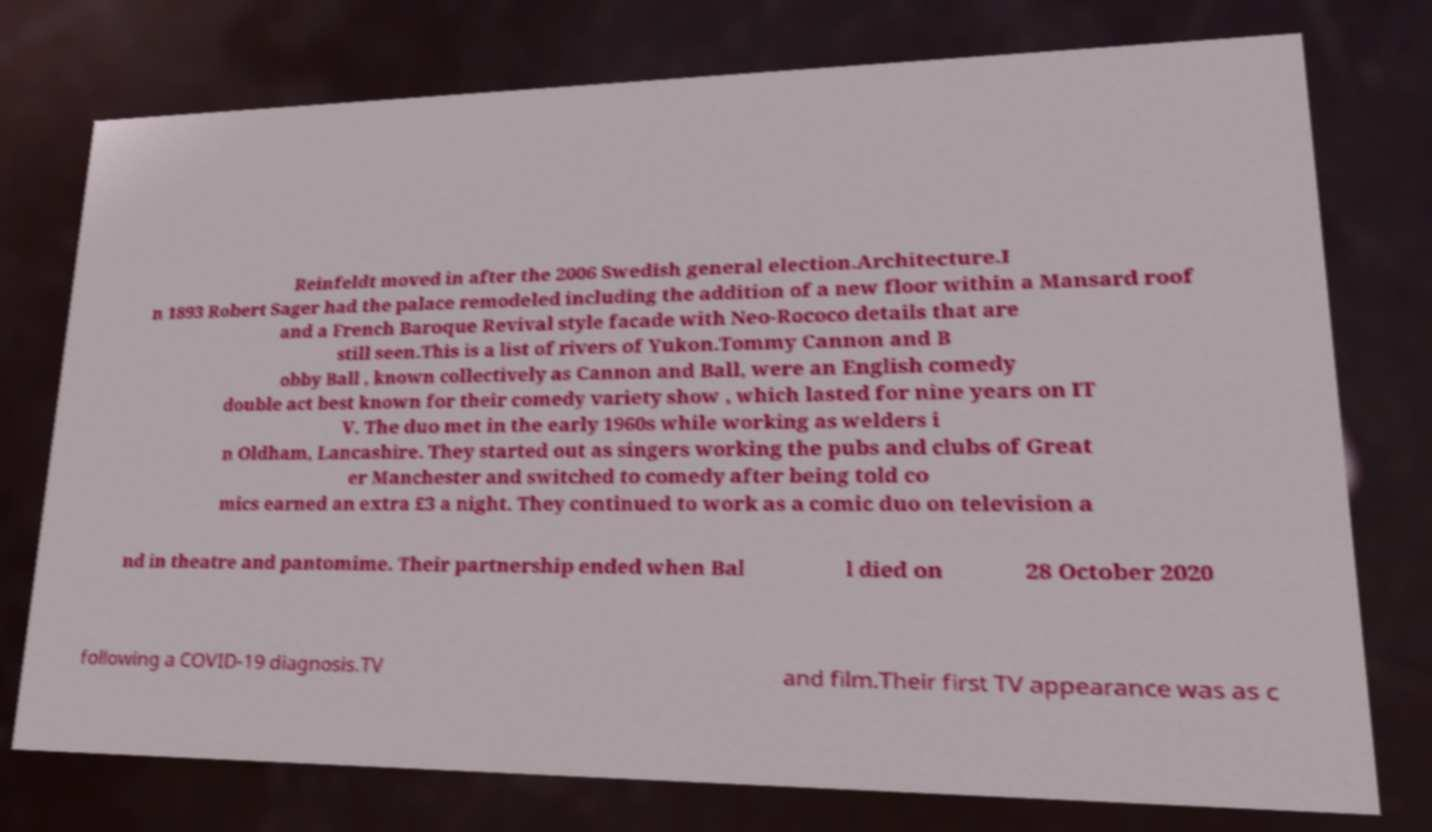Can you read and provide the text displayed in the image?This photo seems to have some interesting text. Can you extract and type it out for me? Reinfeldt moved in after the 2006 Swedish general election.Architecture.I n 1893 Robert Sager had the palace remodeled including the addition of a new floor within a Mansard roof and a French Baroque Revival style facade with Neo-Rococo details that are still seen.This is a list of rivers of Yukon.Tommy Cannon and B obby Ball , known collectively as Cannon and Ball, were an English comedy double act best known for their comedy variety show , which lasted for nine years on IT V. The duo met in the early 1960s while working as welders i n Oldham, Lancashire. They started out as singers working the pubs and clubs of Great er Manchester and switched to comedy after being told co mics earned an extra £3 a night. They continued to work as a comic duo on television a nd in theatre and pantomime. Their partnership ended when Bal l died on 28 October 2020 following a COVID-19 diagnosis.TV and film.Their first TV appearance was as c 